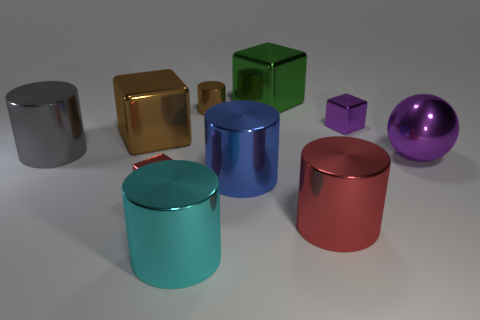Subtract 1 blocks. How many blocks are left? 3 Subtract all red cylinders. How many cylinders are left? 4 Subtract all blue cylinders. How many cylinders are left? 4 Subtract all yellow cylinders. Subtract all green cubes. How many cylinders are left? 5 Subtract all balls. How many objects are left? 9 Subtract 1 brown cubes. How many objects are left? 9 Subtract all brown things. Subtract all gray things. How many objects are left? 7 Add 4 gray shiny objects. How many gray shiny objects are left? 5 Add 8 red metallic cylinders. How many red metallic cylinders exist? 9 